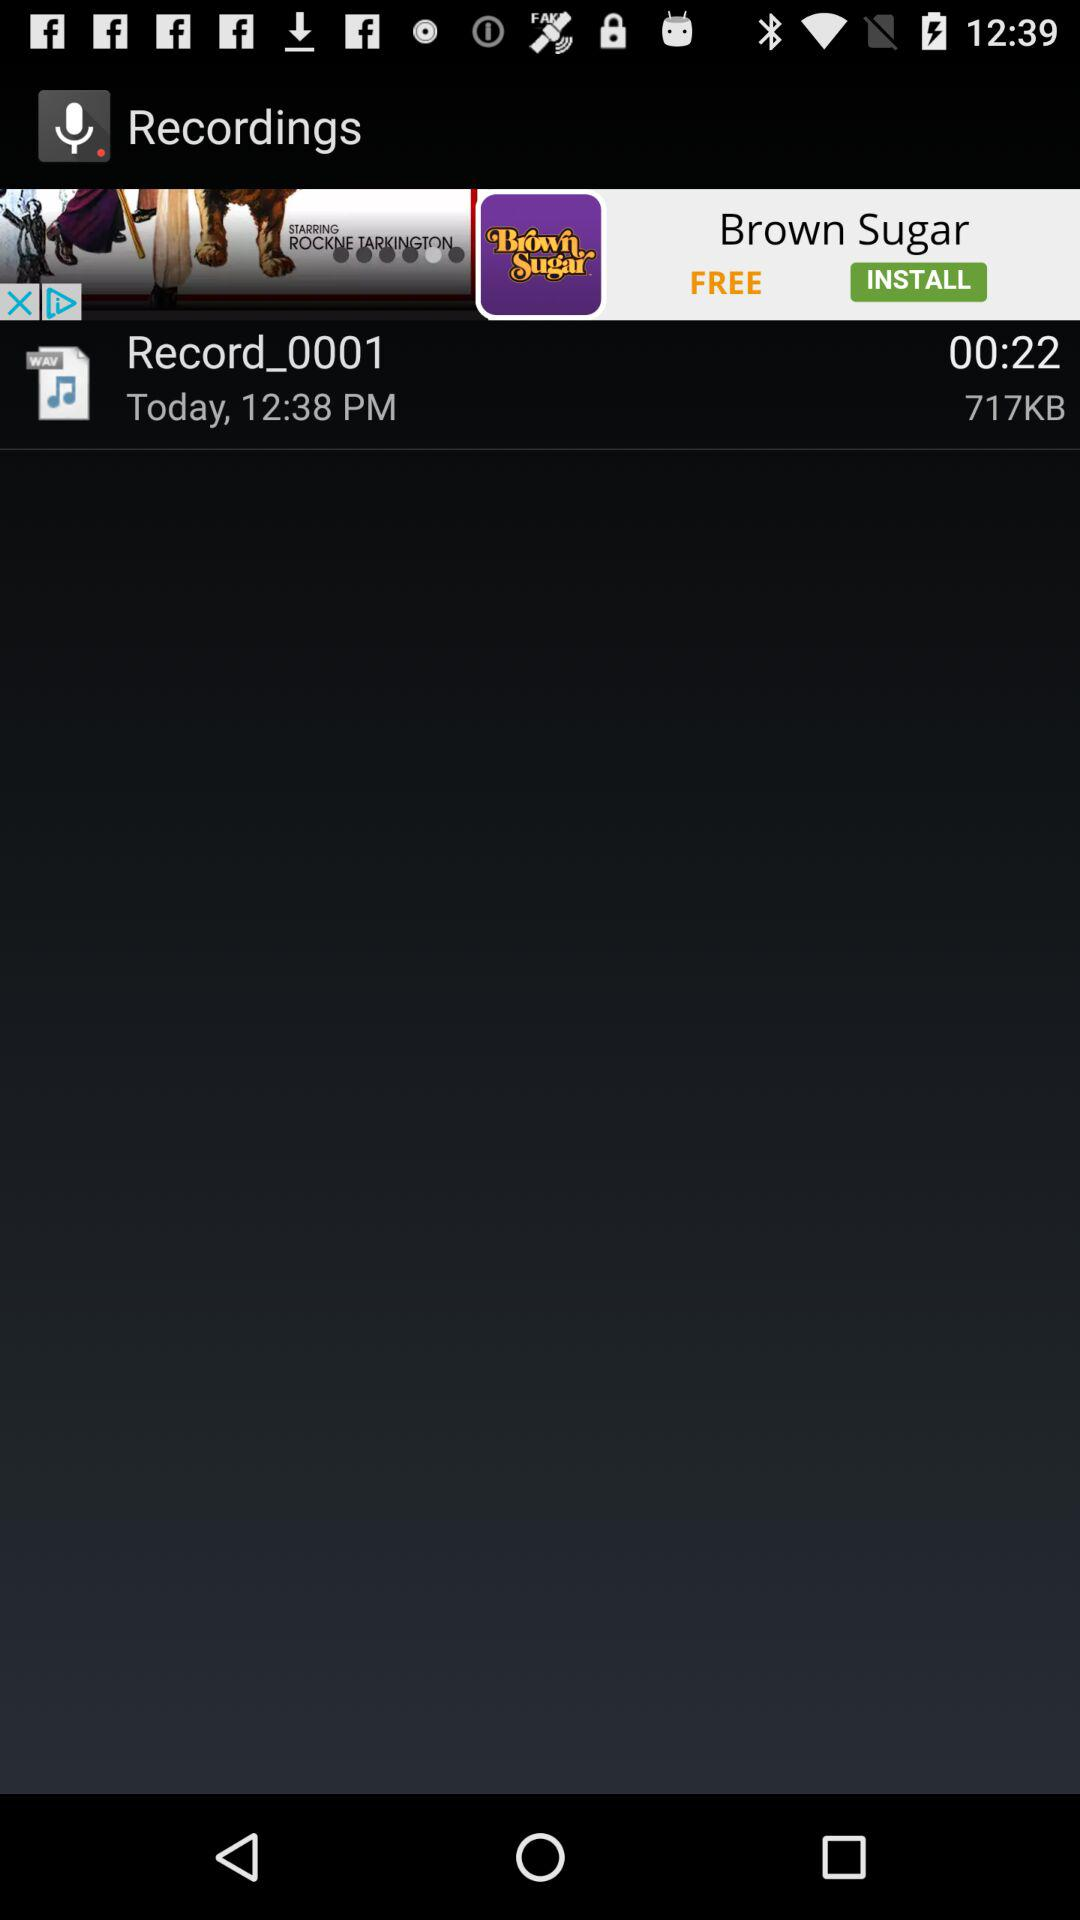What is the recording name? The recording name is Record_0001. 